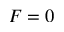<formula> <loc_0><loc_0><loc_500><loc_500>F = 0</formula> 